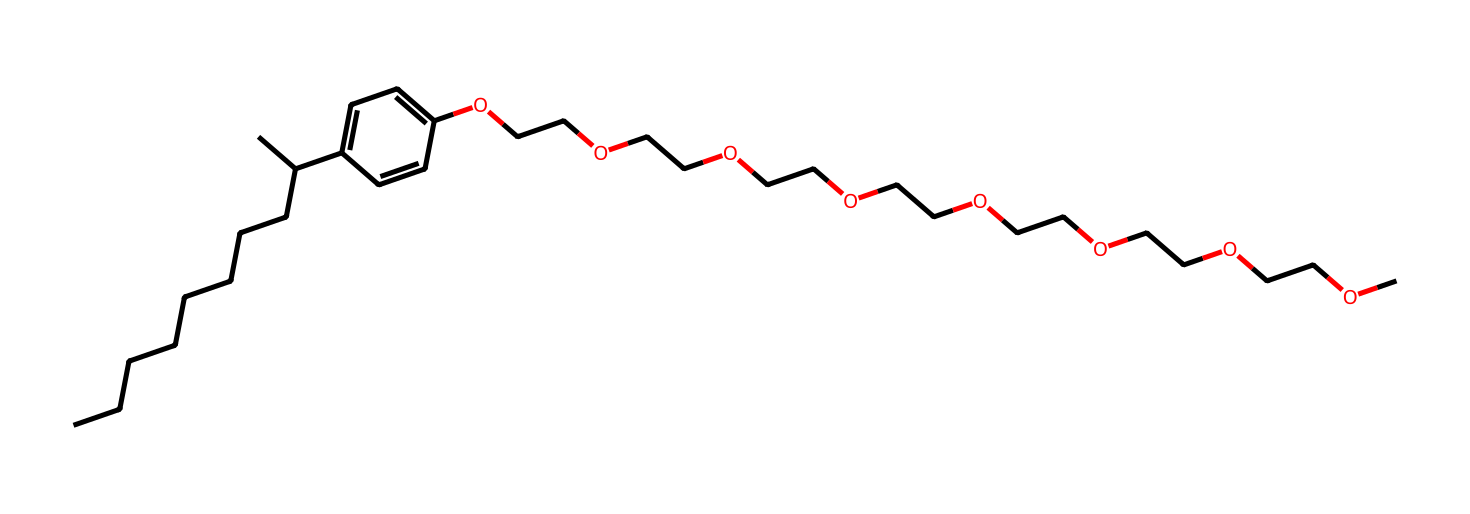What is the main functional group present in nonylphenol ethoxylate? The main functional group in this structure is the phenolic group (indicated by the -OH group attached to the aromatic ring), which classifies it as a nonylphenol derivative.
Answer: phenolic How many ethylene oxide units are present in nonylphenol ethoxylate? By examining the repeating units of -OCC- in the structure, we can count a total of 7 ethylene oxide units connected to the nonylphenol moiety, indicating the extent of ethoxylation.
Answer: 7 What type of solubility does nonylphenol ethoxylate exhibit? The presence of both a hydrophobic nonyl group and multiple hydrophilic ethylene oxide units indicates that this compound has amphiphilic characteristics, making it soluble in both water and organic solvents.
Answer: amphiphilic What is the total number of carbon atoms in nonylphenol ethoxylate? By adding the carbon atoms from the nonyl chain (10 carbons) and those from the ethylene oxide units (14 carbons, considering 7 -OCC- groups), we find that nonylphenol ethoxylate has a total of 24 carbon atoms.
Answer: 24 What kind of interaction is nonylphenol ethoxylate expected to have with oils? Given its long hydrophobic chain and ethylene oxide units, nonylphenol ethoxylate is likely to interact favorably with oils through hydrophobic interactions, helping in the emulsification process.
Answer: hydrophobic interactions 